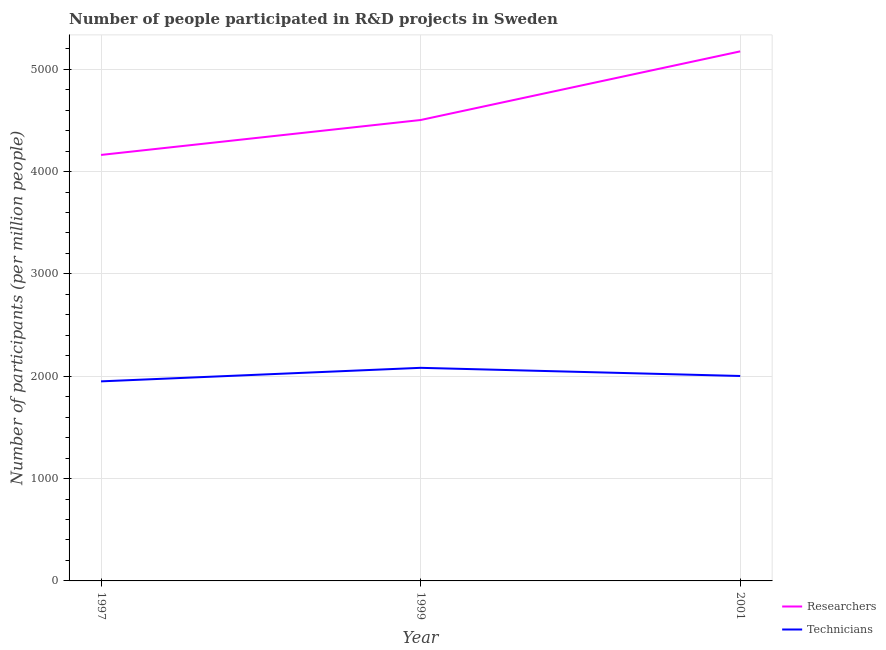How many different coloured lines are there?
Provide a short and direct response. 2. Does the line corresponding to number of technicians intersect with the line corresponding to number of researchers?
Your response must be concise. No. What is the number of researchers in 1999?
Make the answer very short. 4503.9. Across all years, what is the maximum number of technicians?
Make the answer very short. 2082.24. Across all years, what is the minimum number of technicians?
Make the answer very short. 1950. In which year was the number of technicians maximum?
Your answer should be very brief. 1999. In which year was the number of researchers minimum?
Ensure brevity in your answer.  1997. What is the total number of researchers in the graph?
Give a very brief answer. 1.38e+04. What is the difference between the number of researchers in 1999 and that in 2001?
Keep it short and to the point. -670.7. What is the difference between the number of researchers in 1999 and the number of technicians in 2001?
Give a very brief answer. 2501.34. What is the average number of technicians per year?
Give a very brief answer. 2011.6. In the year 2001, what is the difference between the number of researchers and number of technicians?
Offer a very short reply. 3172.04. What is the ratio of the number of technicians in 1997 to that in 2001?
Make the answer very short. 0.97. What is the difference between the highest and the second highest number of technicians?
Provide a short and direct response. 79.67. What is the difference between the highest and the lowest number of technicians?
Offer a very short reply. 132.24. Is the sum of the number of technicians in 1997 and 1999 greater than the maximum number of researchers across all years?
Your answer should be compact. No. What is the difference between two consecutive major ticks on the Y-axis?
Your response must be concise. 1000. Are the values on the major ticks of Y-axis written in scientific E-notation?
Your answer should be very brief. No. Does the graph contain any zero values?
Provide a short and direct response. No. Where does the legend appear in the graph?
Your response must be concise. Bottom right. What is the title of the graph?
Offer a very short reply. Number of people participated in R&D projects in Sweden. What is the label or title of the Y-axis?
Your answer should be very brief. Number of participants (per million people). What is the Number of participants (per million people) of Researchers in 1997?
Give a very brief answer. 4162.72. What is the Number of participants (per million people) in Technicians in 1997?
Give a very brief answer. 1950. What is the Number of participants (per million people) in Researchers in 1999?
Keep it short and to the point. 4503.9. What is the Number of participants (per million people) in Technicians in 1999?
Make the answer very short. 2082.24. What is the Number of participants (per million people) of Researchers in 2001?
Provide a short and direct response. 5174.6. What is the Number of participants (per million people) in Technicians in 2001?
Provide a short and direct response. 2002.57. Across all years, what is the maximum Number of participants (per million people) in Researchers?
Ensure brevity in your answer.  5174.6. Across all years, what is the maximum Number of participants (per million people) in Technicians?
Provide a succinct answer. 2082.24. Across all years, what is the minimum Number of participants (per million people) of Researchers?
Make the answer very short. 4162.72. Across all years, what is the minimum Number of participants (per million people) of Technicians?
Provide a succinct answer. 1950. What is the total Number of participants (per million people) in Researchers in the graph?
Give a very brief answer. 1.38e+04. What is the total Number of participants (per million people) in Technicians in the graph?
Your answer should be compact. 6034.81. What is the difference between the Number of participants (per million people) in Researchers in 1997 and that in 1999?
Ensure brevity in your answer.  -341.18. What is the difference between the Number of participants (per million people) of Technicians in 1997 and that in 1999?
Your response must be concise. -132.24. What is the difference between the Number of participants (per million people) in Researchers in 1997 and that in 2001?
Ensure brevity in your answer.  -1011.88. What is the difference between the Number of participants (per million people) of Technicians in 1997 and that in 2001?
Offer a very short reply. -52.56. What is the difference between the Number of participants (per million people) in Researchers in 1999 and that in 2001?
Make the answer very short. -670.7. What is the difference between the Number of participants (per million people) in Technicians in 1999 and that in 2001?
Your answer should be very brief. 79.67. What is the difference between the Number of participants (per million people) in Researchers in 1997 and the Number of participants (per million people) in Technicians in 1999?
Provide a short and direct response. 2080.48. What is the difference between the Number of participants (per million people) in Researchers in 1997 and the Number of participants (per million people) in Technicians in 2001?
Provide a short and direct response. 2160.15. What is the difference between the Number of participants (per million people) in Researchers in 1999 and the Number of participants (per million people) in Technicians in 2001?
Offer a terse response. 2501.34. What is the average Number of participants (per million people) in Researchers per year?
Your answer should be compact. 4613.74. What is the average Number of participants (per million people) in Technicians per year?
Give a very brief answer. 2011.6. In the year 1997, what is the difference between the Number of participants (per million people) in Researchers and Number of participants (per million people) in Technicians?
Offer a very short reply. 2212.72. In the year 1999, what is the difference between the Number of participants (per million people) in Researchers and Number of participants (per million people) in Technicians?
Provide a short and direct response. 2421.66. In the year 2001, what is the difference between the Number of participants (per million people) of Researchers and Number of participants (per million people) of Technicians?
Provide a short and direct response. 3172.04. What is the ratio of the Number of participants (per million people) of Researchers in 1997 to that in 1999?
Offer a very short reply. 0.92. What is the ratio of the Number of participants (per million people) of Technicians in 1997 to that in 1999?
Offer a very short reply. 0.94. What is the ratio of the Number of participants (per million people) in Researchers in 1997 to that in 2001?
Provide a short and direct response. 0.8. What is the ratio of the Number of participants (per million people) of Technicians in 1997 to that in 2001?
Ensure brevity in your answer.  0.97. What is the ratio of the Number of participants (per million people) in Researchers in 1999 to that in 2001?
Provide a succinct answer. 0.87. What is the ratio of the Number of participants (per million people) of Technicians in 1999 to that in 2001?
Give a very brief answer. 1.04. What is the difference between the highest and the second highest Number of participants (per million people) in Researchers?
Offer a very short reply. 670.7. What is the difference between the highest and the second highest Number of participants (per million people) of Technicians?
Ensure brevity in your answer.  79.67. What is the difference between the highest and the lowest Number of participants (per million people) of Researchers?
Your response must be concise. 1011.88. What is the difference between the highest and the lowest Number of participants (per million people) in Technicians?
Offer a terse response. 132.24. 